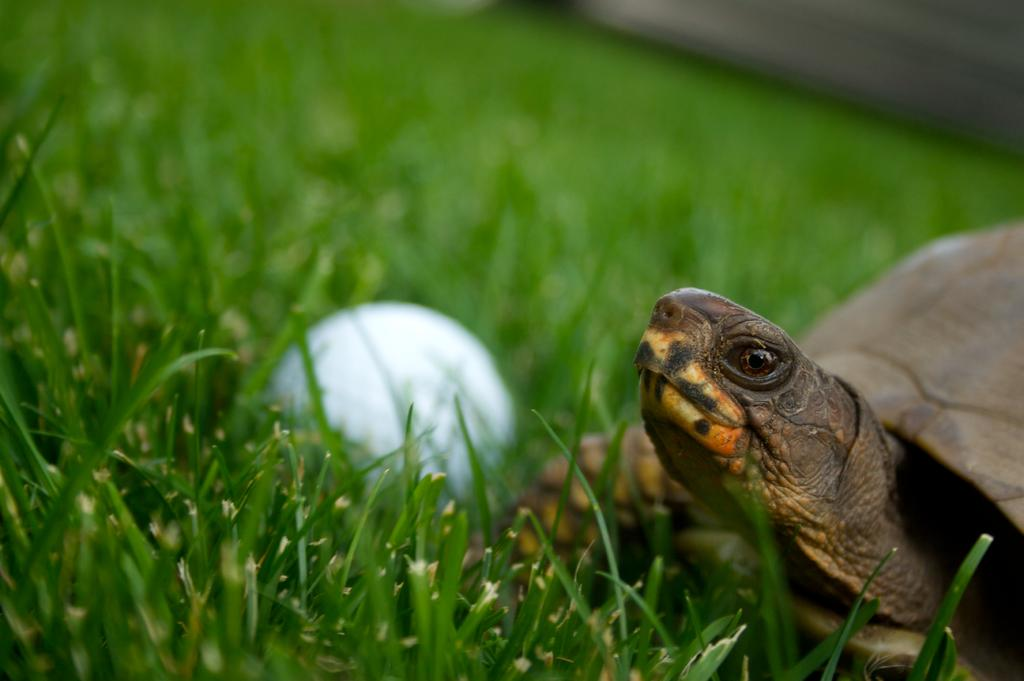What type of animal is in the image? There is a tortoise in the image. What other object can be seen in the image besides the tortoise? There is a white object in the image. Where are the tortoise and the white object located? They are on grassy land. How many pigs are playing in the sand at the seashore in the image? There are no pigs or seashore present in the image; it features a tortoise and a white object on grassy land. 